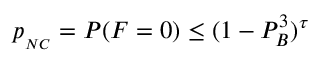<formula> <loc_0><loc_0><loc_500><loc_500>p _ { _ { N C } } = P ( F = 0 ) \leq ( 1 - P _ { B } ^ { 3 } ) ^ { \tau }</formula> 